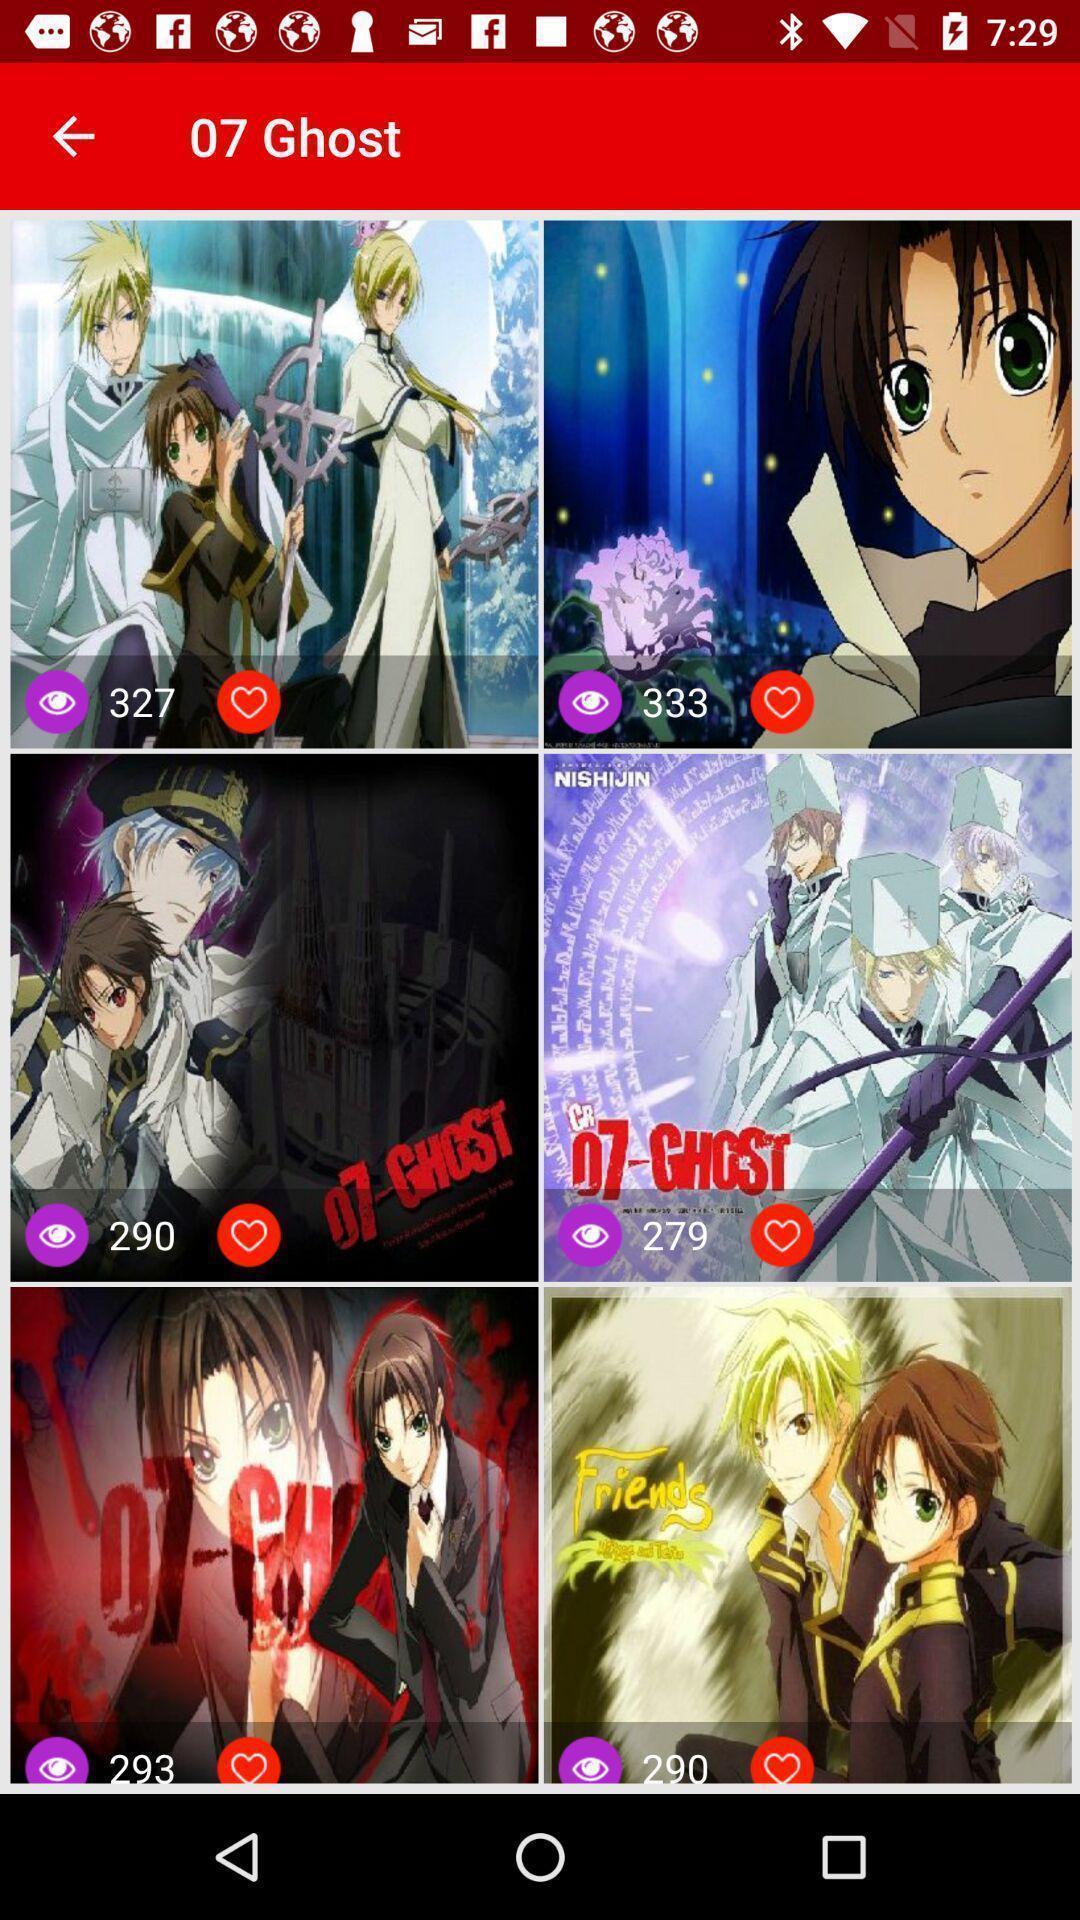Describe the content in this image. Screen page displaying various images. 